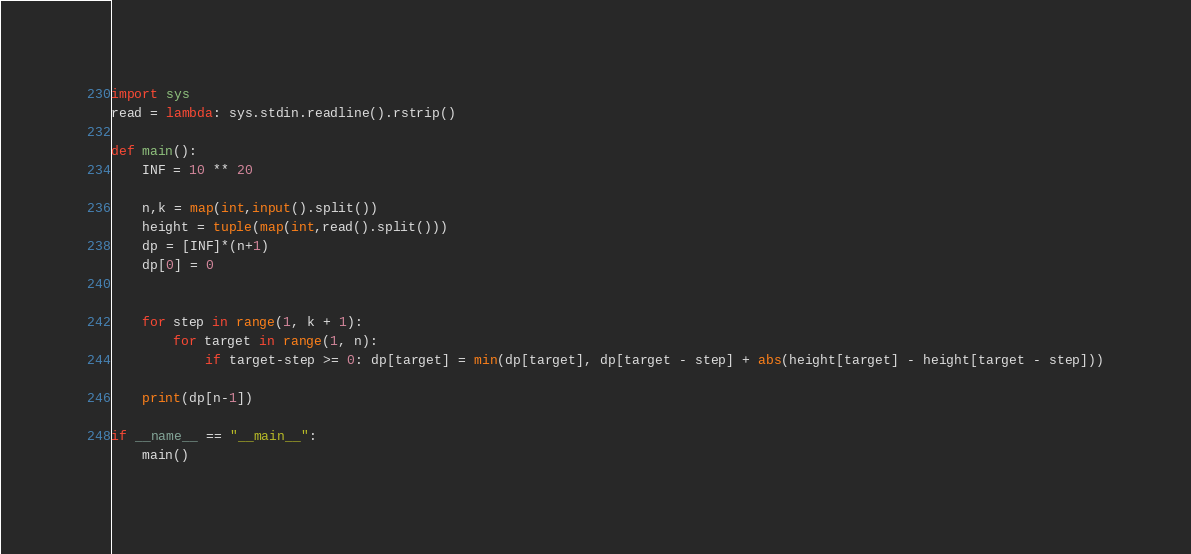<code> <loc_0><loc_0><loc_500><loc_500><_Python_>import sys
read = lambda: sys.stdin.readline().rstrip()
 
def main():
    INF = 10 ** 20
 
    n,k = map(int,input().split())
    height = tuple(map(int,read().split()))
    dp = [INF]*(n+1)
    dp[0] = 0
 
    
    for step in range(1, k + 1):
    	for target in range(1, n):
            if target-step >= 0: dp[target] = min(dp[target], dp[target - step] + abs(height[target] - height[target - step]))
 
    print(dp[n-1])

if __name__ == "__main__":
    main()</code> 